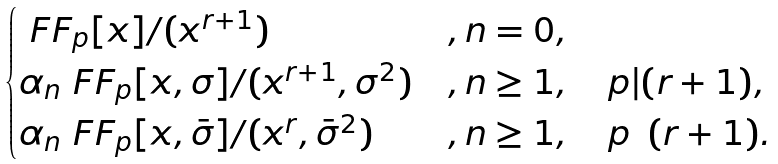Convert formula to latex. <formula><loc_0><loc_0><loc_500><loc_500>\begin{cases} \ F F _ { p } [ x ] / ( x ^ { r + 1 } ) & , n = 0 , \\ \alpha _ { n } \ F F _ { p } [ x , \sigma ] / ( x ^ { r + 1 } , \sigma ^ { 2 } ) & , n \geq 1 , \quad p | ( r + 1 ) , \\ \alpha _ { n } \ F F _ { p } [ x , \bar { \sigma } ] / ( x ^ { r } , \bar { \sigma } ^ { 2 } ) & , n \geq 1 , \quad p \nmid ( r + 1 ) . \\ \end{cases}</formula> 